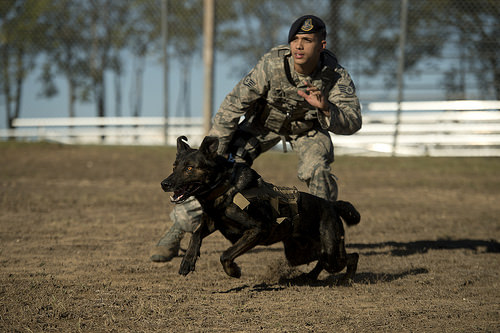<image>
Is there a dog behind the man? No. The dog is not behind the man. From this viewpoint, the dog appears to be positioned elsewhere in the scene. Is the dog next to the man? Yes. The dog is positioned adjacent to the man, located nearby in the same general area. 